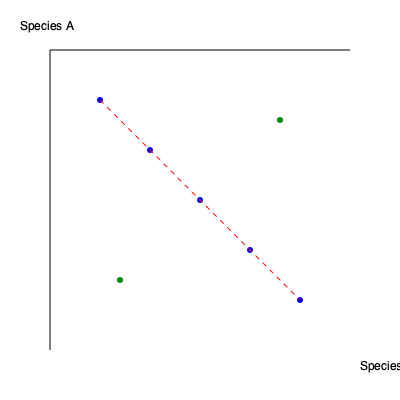Analyze the dot plot comparing genomic sequences of Species A and Species B. What does the diagonal line of blue dots suggest about the relationship between these species' genomes, and what might the two isolated green dots represent? 1. Diagonal line of blue dots:
   - In a genomic dot plot, a diagonal line indicates regions of sequence similarity between the two species.
   - The blue dots forming a diagonal line from top-left to bottom-right suggest that there are long stretches of conserved sequences between Species A and Species B.
   - This pattern implies that these regions have remained relatively unchanged during evolution, indicating functional importance.

2. Significance of the diagonal:
   - The presence of a strong diagonal line suggests that Species A and Species B are closely related evolutionarily.
   - It indicates that a significant portion of their genomes has been conserved since their last common ancestor.

3. Isolated green dots:
   - The two green dots off the main diagonal represent short regions of sequence similarity that are in different locations in the two genomes.
   - These could indicate:
     a) Genomic rearrangements: A gene or sequence that has moved to a different location in one of the species.
     b) Duplications: A gene that has been duplicated in one species but not the other.
     c) Horizontal gene transfer: A sequence that was acquired by one species from a different source.

4. Interpretation:
   - The overall pattern suggests that Species A and Species B share a recent common ancestor and have maintained significant genomic similarity.
   - However, the presence of the isolated green dots indicates that some genomic changes have occurred since their divergence, potentially contributing to species-specific traits or adaptations.
Answer: Conserved genomic regions with some rearrangements or duplications 